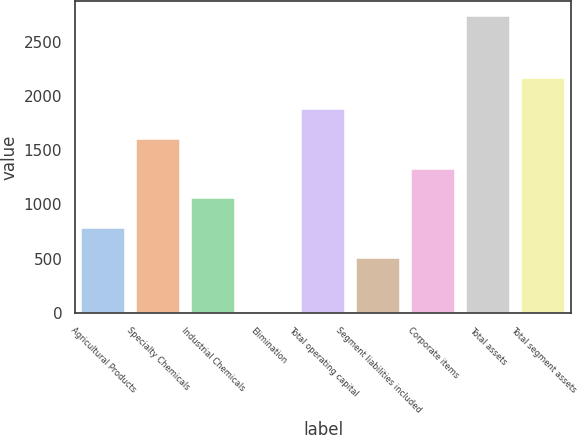Convert chart. <chart><loc_0><loc_0><loc_500><loc_500><bar_chart><fcel>Agricultural Products<fcel>Specialty Chemicals<fcel>Industrial Chemicals<fcel>Elimination<fcel>Total operating capital<fcel>Segment liabilities included<fcel>Corporate items<fcel>Total assets<fcel>Total segment assets<nl><fcel>782.08<fcel>1604.02<fcel>1056.06<fcel>0.2<fcel>1878<fcel>508.1<fcel>1330.04<fcel>2740<fcel>2160.4<nl></chart> 